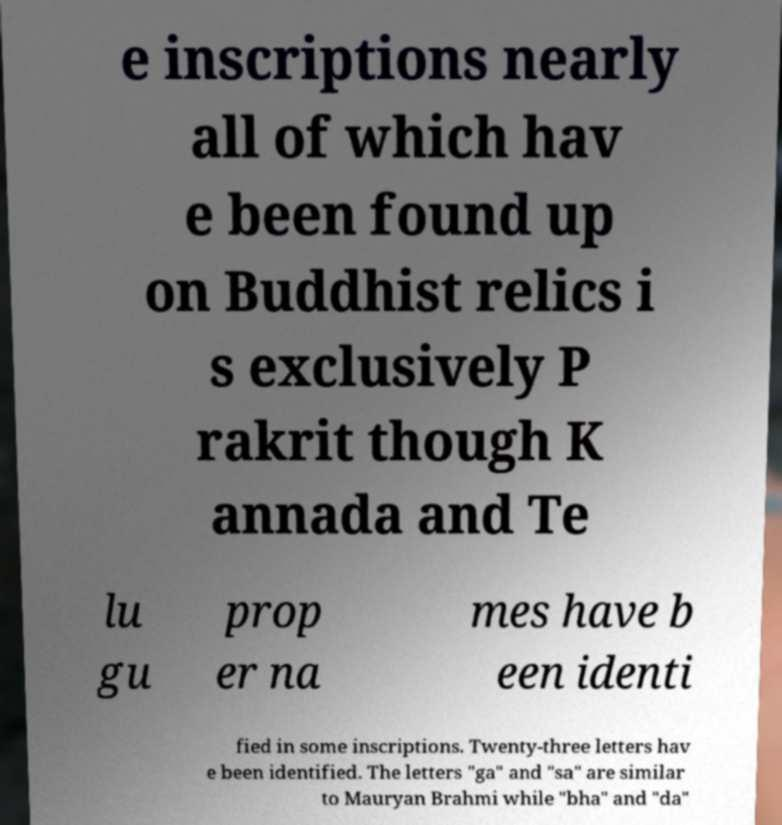Please identify and transcribe the text found in this image. e inscriptions nearly all of which hav e been found up on Buddhist relics i s exclusively P rakrit though K annada and Te lu gu prop er na mes have b een identi fied in some inscriptions. Twenty-three letters hav e been identified. The letters "ga" and "sa" are similar to Mauryan Brahmi while "bha" and "da" 